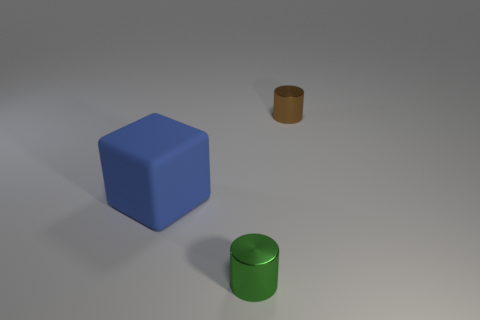Is there anything else that is made of the same material as the big cube?
Your response must be concise. No. What is the size of the matte object that is in front of the brown thing?
Provide a succinct answer. Large. Is there a small brown cylinder that has the same material as the green object?
Your answer should be very brief. Yes. What number of other objects are the same shape as the small brown metallic thing?
Offer a terse response. 1. What is the shape of the green metallic thing that is in front of the metallic object that is on the right side of the green metal cylinder that is in front of the big rubber thing?
Keep it short and to the point. Cylinder. There is a thing that is left of the small brown cylinder and behind the tiny green cylinder; what material is it made of?
Provide a succinct answer. Rubber. There is a metallic cylinder that is in front of the blue block; does it have the same size as the blue thing?
Your answer should be compact. No. Is there anything else that is the same size as the blue rubber thing?
Make the answer very short. No. Are there more green things in front of the blue block than small green metallic cylinders to the right of the small brown shiny cylinder?
Keep it short and to the point. Yes. The rubber block left of the tiny thing left of the metallic cylinder that is behind the matte object is what color?
Make the answer very short. Blue. 